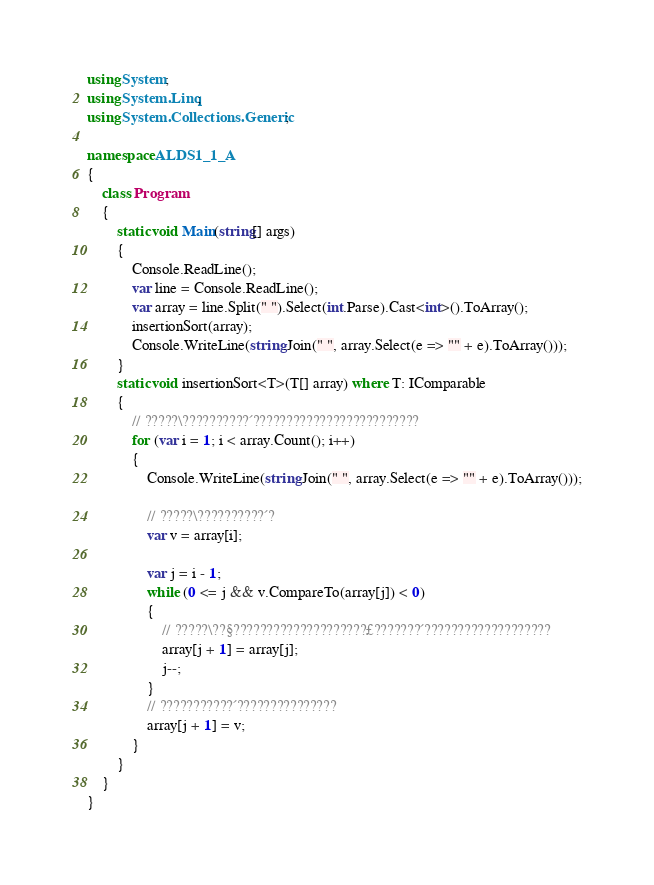<code> <loc_0><loc_0><loc_500><loc_500><_C#_>using System;
using System.Linq;
using System.Collections.Generic;

namespace ALDS1_1_A
{
    class Program
    {
        static void Main(string[] args)
        {
            Console.ReadLine();
            var line = Console.ReadLine();
            var array = line.Split(" ").Select(int.Parse).Cast<int>().ToArray();
            insertionSort(array);
            Console.WriteLine(string.Join(" ", array.Select(e => "" + e).ToArray()));
        }
        static void insertionSort<T>(T[] array) where T: IComparable
        {
            // ?????\??????????´?????????????????????????
            for (var i = 1; i < array.Count(); i++)
            {
                Console.WriteLine(string.Join(" ", array.Select(e => "" + e).ToArray()));

                // ?????\??????????´?
                var v = array[i];

                var j = i - 1;
                while (0 <= j && v.CompareTo(array[j]) < 0)
                {
                    // ?????\??§????????????????????£???????´???????????????????
                    array[j + 1] = array[j];
                    j--;
                }
                // ???????????´???????????????
                array[j + 1] = v;
            }
        }
    }
}</code> 